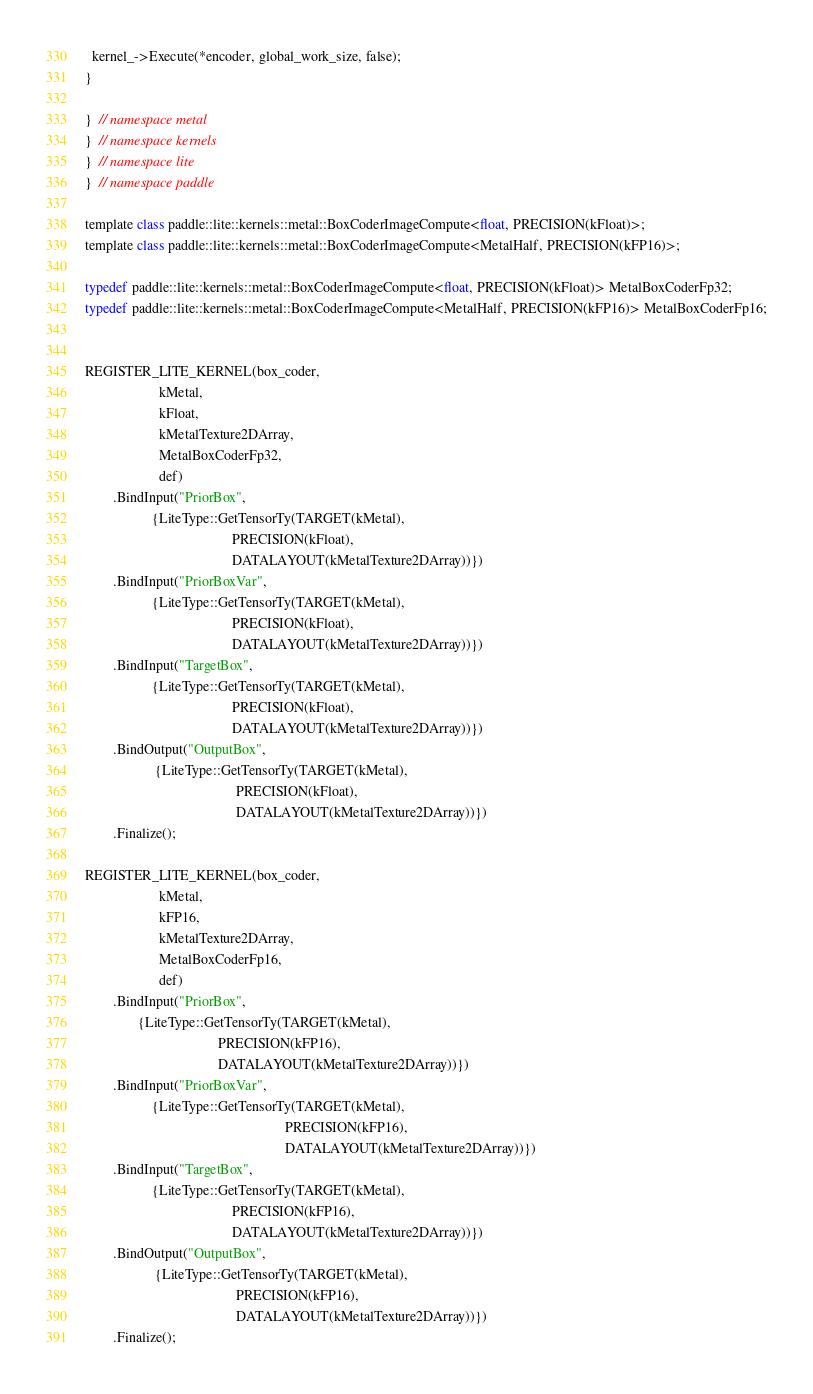Convert code to text. <code><loc_0><loc_0><loc_500><loc_500><_ObjectiveC_>
  kernel_->Execute(*encoder, global_work_size, false);
}

}  // namespace metal
}  // namespace kernels
}  // namespace lite
}  // namespace paddle

template class paddle::lite::kernels::metal::BoxCoderImageCompute<float, PRECISION(kFloat)>;
template class paddle::lite::kernels::metal::BoxCoderImageCompute<MetalHalf, PRECISION(kFP16)>;

typedef paddle::lite::kernels::metal::BoxCoderImageCompute<float, PRECISION(kFloat)> MetalBoxCoderFp32;
typedef paddle::lite::kernels::metal::BoxCoderImageCompute<MetalHalf, PRECISION(kFP16)> MetalBoxCoderFp16;


REGISTER_LITE_KERNEL(box_coder,
                     kMetal,
                     kFloat,
                     kMetalTexture2DArray,
                     MetalBoxCoderFp32,
                     def)
        .BindInput("PriorBox",
                   {LiteType::GetTensorTy(TARGET(kMetal),
                                          PRECISION(kFloat),
                                          DATALAYOUT(kMetalTexture2DArray))})
        .BindInput("PriorBoxVar",
                   {LiteType::GetTensorTy(TARGET(kMetal),
                                          PRECISION(kFloat),
                                          DATALAYOUT(kMetalTexture2DArray))})
        .BindInput("TargetBox",
                   {LiteType::GetTensorTy(TARGET(kMetal),
                                          PRECISION(kFloat),
                                          DATALAYOUT(kMetalTexture2DArray))})
        .BindOutput("OutputBox",
                    {LiteType::GetTensorTy(TARGET(kMetal),
                                           PRECISION(kFloat),
                                           DATALAYOUT(kMetalTexture2DArray))})
        .Finalize();

REGISTER_LITE_KERNEL(box_coder,
                     kMetal,
                     kFP16,
                     kMetalTexture2DArray,
                     MetalBoxCoderFp16,
                     def)
        .BindInput("PriorBox",
               {LiteType::GetTensorTy(TARGET(kMetal),
                                      PRECISION(kFP16),
                                      DATALAYOUT(kMetalTexture2DArray))})
        .BindInput("PriorBoxVar",
                   {LiteType::GetTensorTy(TARGET(kMetal),
                                                         PRECISION(kFP16),
                                                         DATALAYOUT(kMetalTexture2DArray))})
        .BindInput("TargetBox",
                   {LiteType::GetTensorTy(TARGET(kMetal),
                                          PRECISION(kFP16),
                                          DATALAYOUT(kMetalTexture2DArray))})
        .BindOutput("OutputBox",
                    {LiteType::GetTensorTy(TARGET(kMetal),
                                           PRECISION(kFP16),
                                           DATALAYOUT(kMetalTexture2DArray))})
        .Finalize();
</code> 